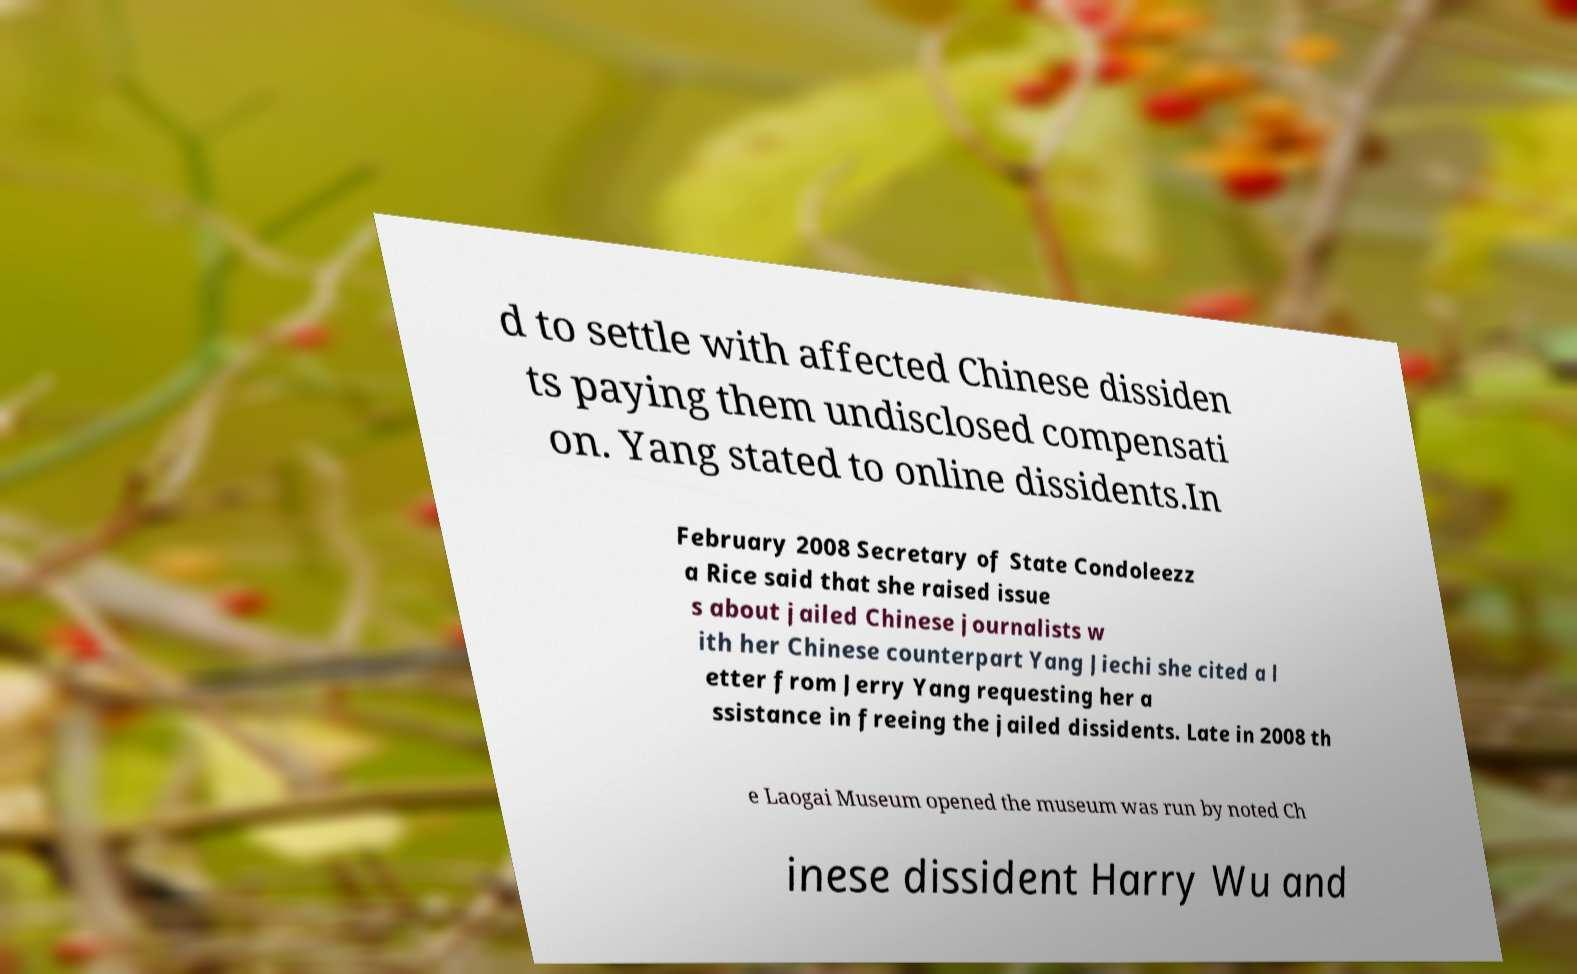I need the written content from this picture converted into text. Can you do that? d to settle with affected Chinese dissiden ts paying them undisclosed compensati on. Yang stated to online dissidents.In February 2008 Secretary of State Condoleezz a Rice said that she raised issue s about jailed Chinese journalists w ith her Chinese counterpart Yang Jiechi she cited a l etter from Jerry Yang requesting her a ssistance in freeing the jailed dissidents. Late in 2008 th e Laogai Museum opened the museum was run by noted Ch inese dissident Harry Wu and 